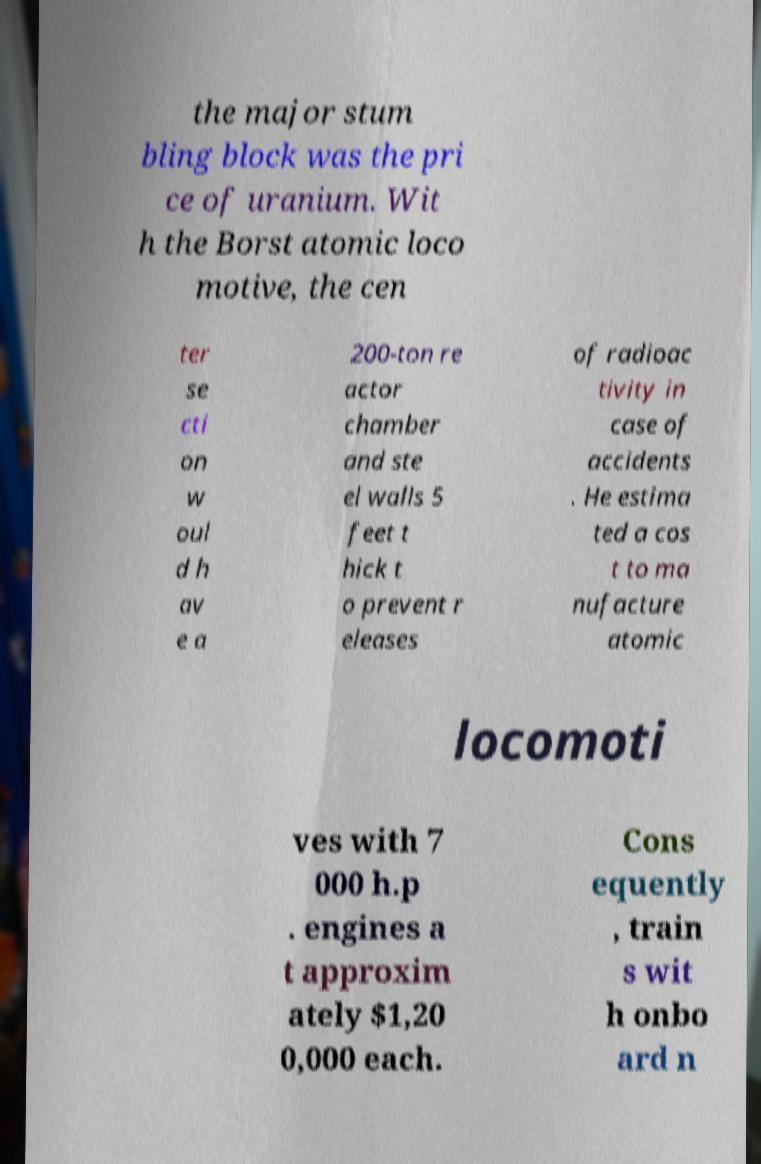Please identify and transcribe the text found in this image. the major stum bling block was the pri ce of uranium. Wit h the Borst atomic loco motive, the cen ter se cti on w oul d h av e a 200-ton re actor chamber and ste el walls 5 feet t hick t o prevent r eleases of radioac tivity in case of accidents . He estima ted a cos t to ma nufacture atomic locomoti ves with 7 000 h.p . engines a t approxim ately $1,20 0,000 each. Cons equently , train s wit h onbo ard n 